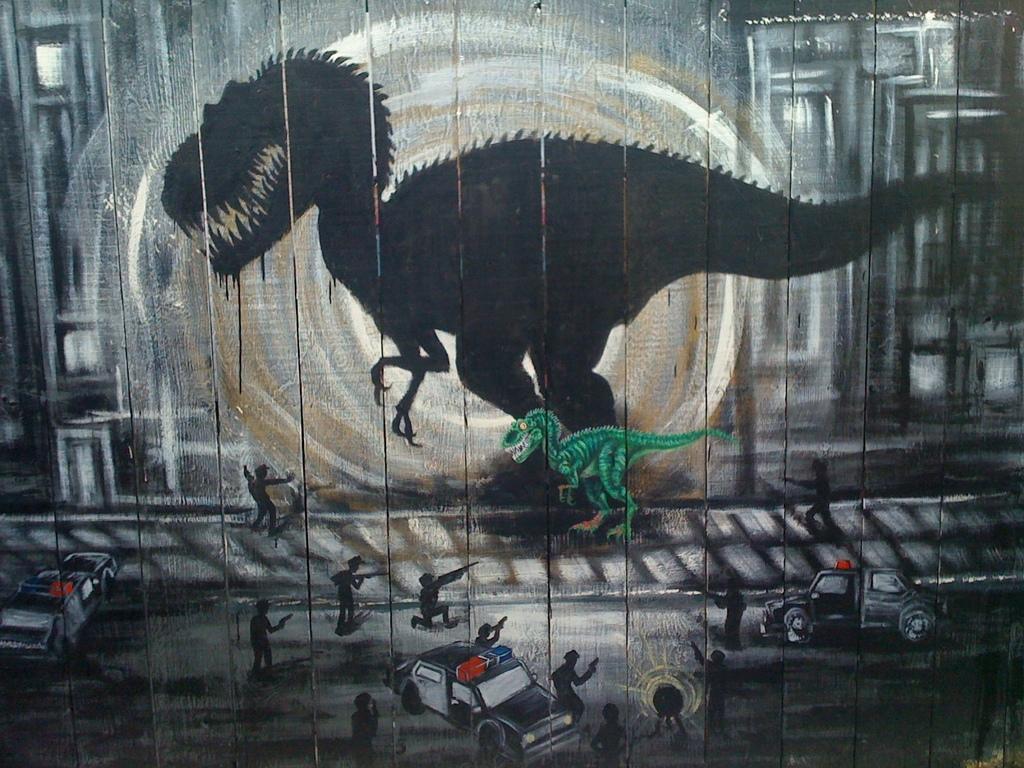Please provide a concise description of this image. In this painting where there is a dinosaur. Here there is the reflection of the dinosaur. In the bottom there are many people with guns and few vehicles are there. 